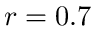Convert formula to latex. <formula><loc_0><loc_0><loc_500><loc_500>r = 0 . 7</formula> 